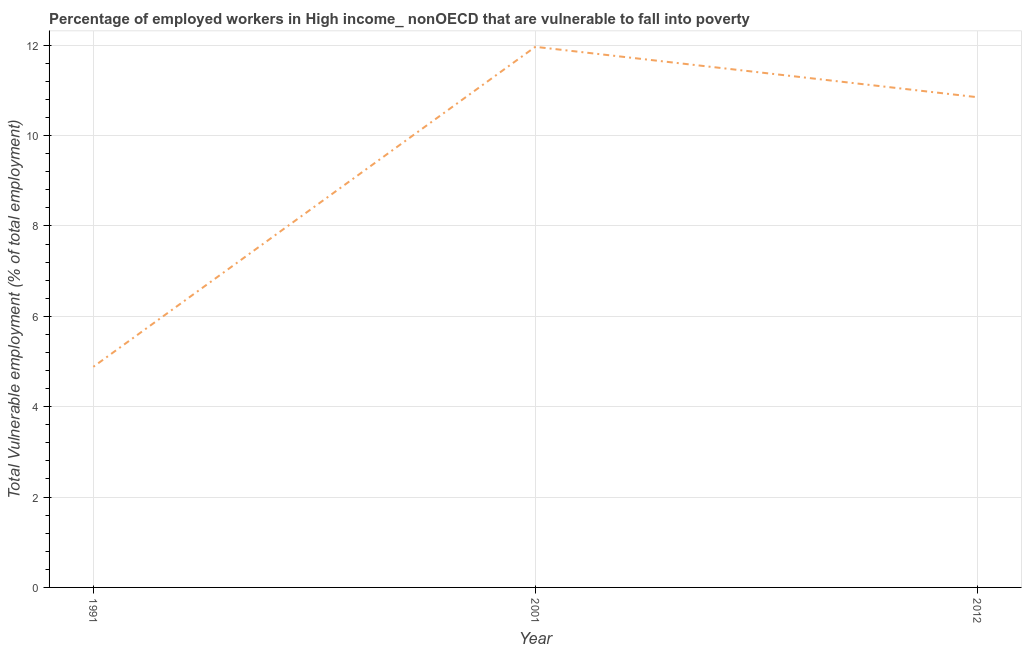What is the total vulnerable employment in 1991?
Give a very brief answer. 4.88. Across all years, what is the maximum total vulnerable employment?
Ensure brevity in your answer.  11.96. Across all years, what is the minimum total vulnerable employment?
Give a very brief answer. 4.88. In which year was the total vulnerable employment minimum?
Your answer should be compact. 1991. What is the sum of the total vulnerable employment?
Offer a terse response. 27.7. What is the difference between the total vulnerable employment in 1991 and 2012?
Make the answer very short. -5.97. What is the average total vulnerable employment per year?
Your answer should be very brief. 9.23. What is the median total vulnerable employment?
Give a very brief answer. 10.85. Do a majority of the years between 2001 and 1991 (inclusive) have total vulnerable employment greater than 6.8 %?
Give a very brief answer. No. What is the ratio of the total vulnerable employment in 1991 to that in 2012?
Your answer should be compact. 0.45. Is the total vulnerable employment in 2001 less than that in 2012?
Offer a very short reply. No. What is the difference between the highest and the second highest total vulnerable employment?
Make the answer very short. 1.11. Is the sum of the total vulnerable employment in 1991 and 2001 greater than the maximum total vulnerable employment across all years?
Offer a very short reply. Yes. What is the difference between the highest and the lowest total vulnerable employment?
Ensure brevity in your answer.  7.08. How many lines are there?
Offer a very short reply. 1. What is the difference between two consecutive major ticks on the Y-axis?
Give a very brief answer. 2. Are the values on the major ticks of Y-axis written in scientific E-notation?
Your answer should be very brief. No. Does the graph contain any zero values?
Provide a short and direct response. No. Does the graph contain grids?
Your response must be concise. Yes. What is the title of the graph?
Make the answer very short. Percentage of employed workers in High income_ nonOECD that are vulnerable to fall into poverty. What is the label or title of the Y-axis?
Provide a short and direct response. Total Vulnerable employment (% of total employment). What is the Total Vulnerable employment (% of total employment) of 1991?
Make the answer very short. 4.88. What is the Total Vulnerable employment (% of total employment) in 2001?
Ensure brevity in your answer.  11.96. What is the Total Vulnerable employment (% of total employment) in 2012?
Give a very brief answer. 10.85. What is the difference between the Total Vulnerable employment (% of total employment) in 1991 and 2001?
Provide a succinct answer. -7.08. What is the difference between the Total Vulnerable employment (% of total employment) in 1991 and 2012?
Offer a very short reply. -5.97. What is the difference between the Total Vulnerable employment (% of total employment) in 2001 and 2012?
Provide a short and direct response. 1.11. What is the ratio of the Total Vulnerable employment (% of total employment) in 1991 to that in 2001?
Your response must be concise. 0.41. What is the ratio of the Total Vulnerable employment (% of total employment) in 1991 to that in 2012?
Keep it short and to the point. 0.45. What is the ratio of the Total Vulnerable employment (% of total employment) in 2001 to that in 2012?
Provide a short and direct response. 1.1. 